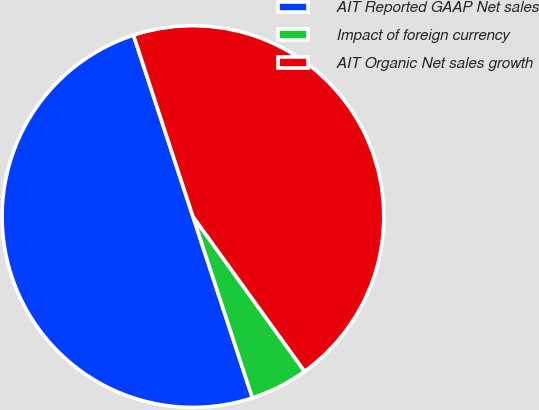<chart> <loc_0><loc_0><loc_500><loc_500><pie_chart><fcel>AIT Reported GAAP Net sales<fcel>Impact of foreign currency<fcel>AIT Organic Net sales growth<nl><fcel>50.0%<fcel>4.9%<fcel>45.1%<nl></chart> 